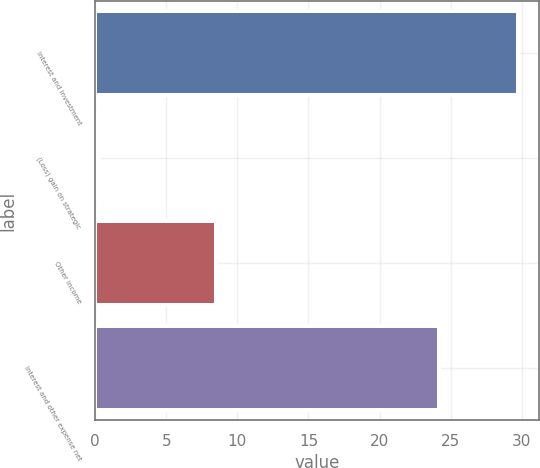Convert chart to OTSL. <chart><loc_0><loc_0><loc_500><loc_500><bar_chart><fcel>Interest and investment<fcel>(Loss) gain on strategic<fcel>Other income<fcel>Interest and other expense net<nl><fcel>29.7<fcel>0.3<fcel>8.5<fcel>24.2<nl></chart> 